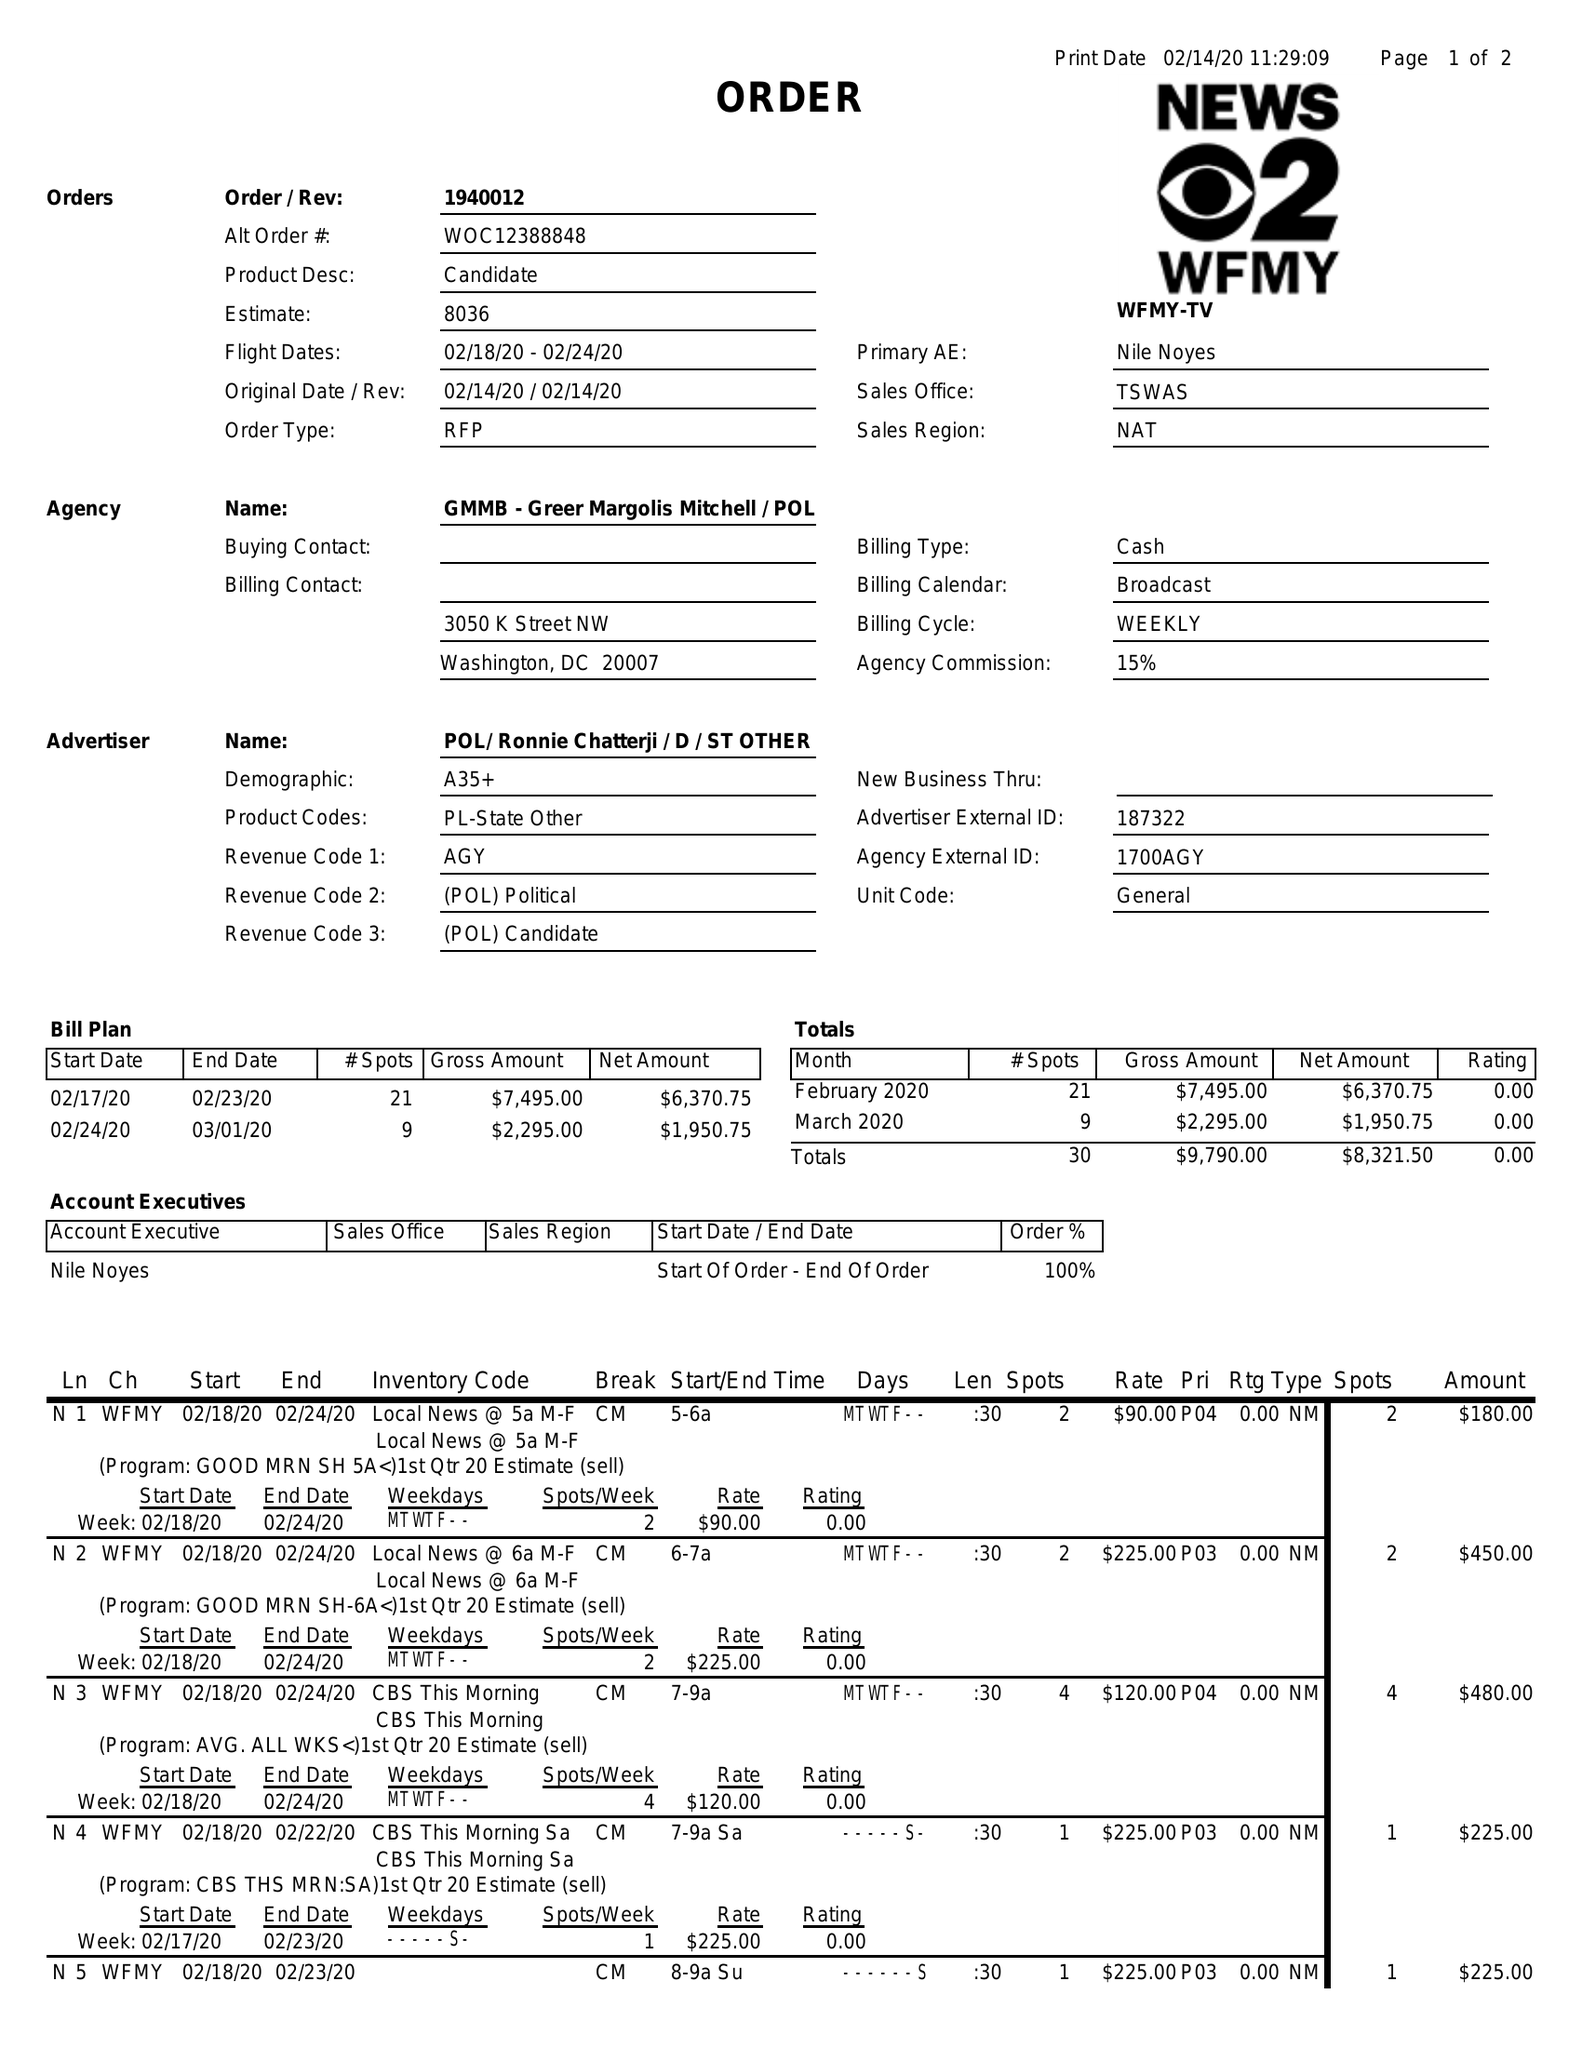What is the value for the flight_from?
Answer the question using a single word or phrase. 02/18/20 